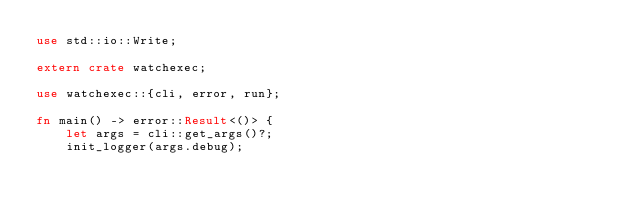<code> <loc_0><loc_0><loc_500><loc_500><_Rust_>use std::io::Write;

extern crate watchexec;

use watchexec::{cli, error, run};

fn main() -> error::Result<()> {
    let args = cli::get_args()?;
    init_logger(args.debug);</code> 